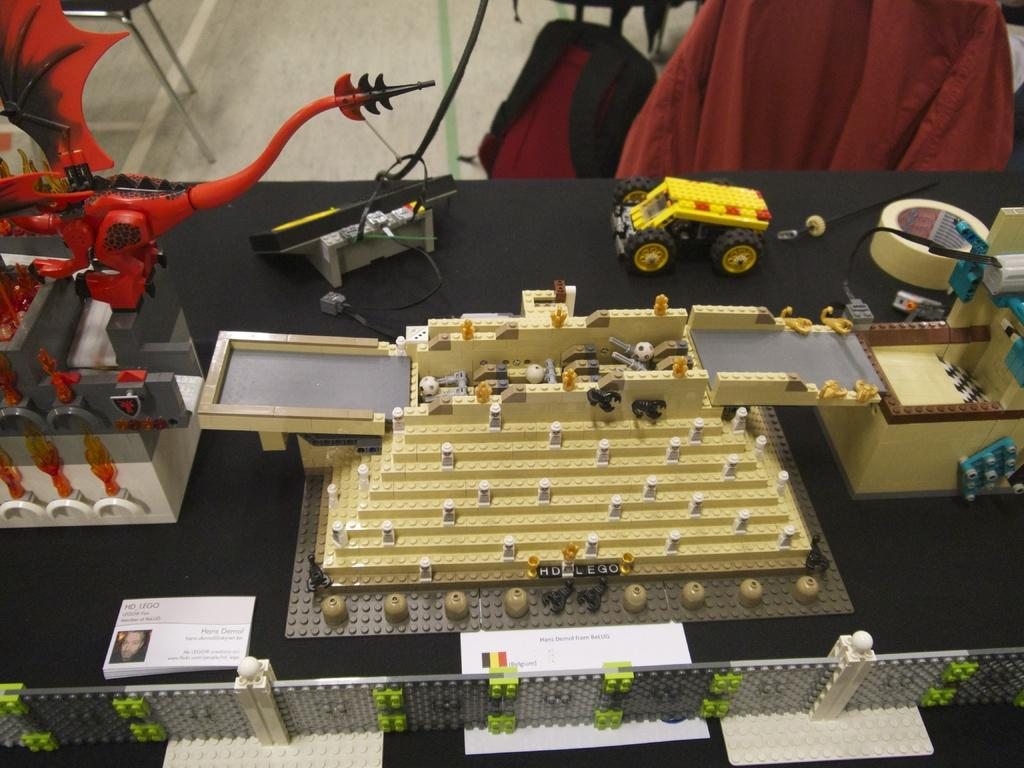What type of toys can be seen in the background of the image? There are vehicle toys in the background of the image. What material are the houses in the image made of? The houses in the image are built with bricks. What type of stamp can be seen on the ear of the copper statue in the image? There is no stamp, ear, or copper statue present in the image. 